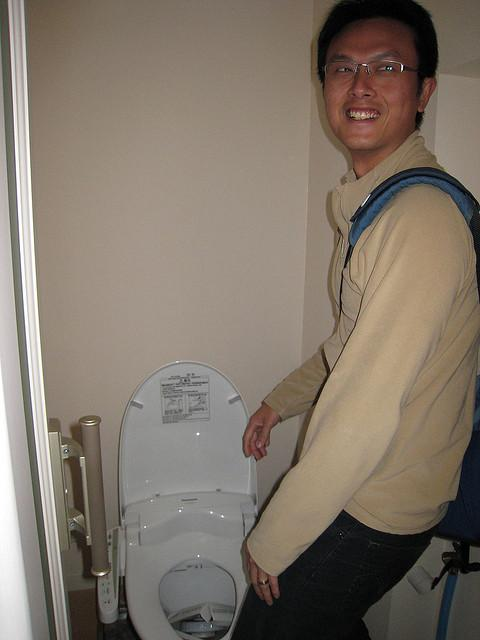What is the man ready to do next? flush 